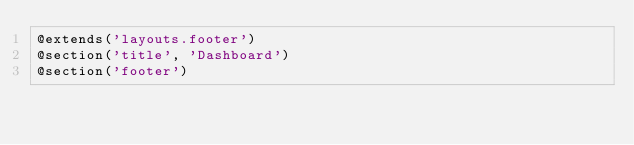<code> <loc_0><loc_0><loc_500><loc_500><_PHP_>@extends('layouts.footer')
@section('title', 'Dashboard')
@section('footer')
</code> 